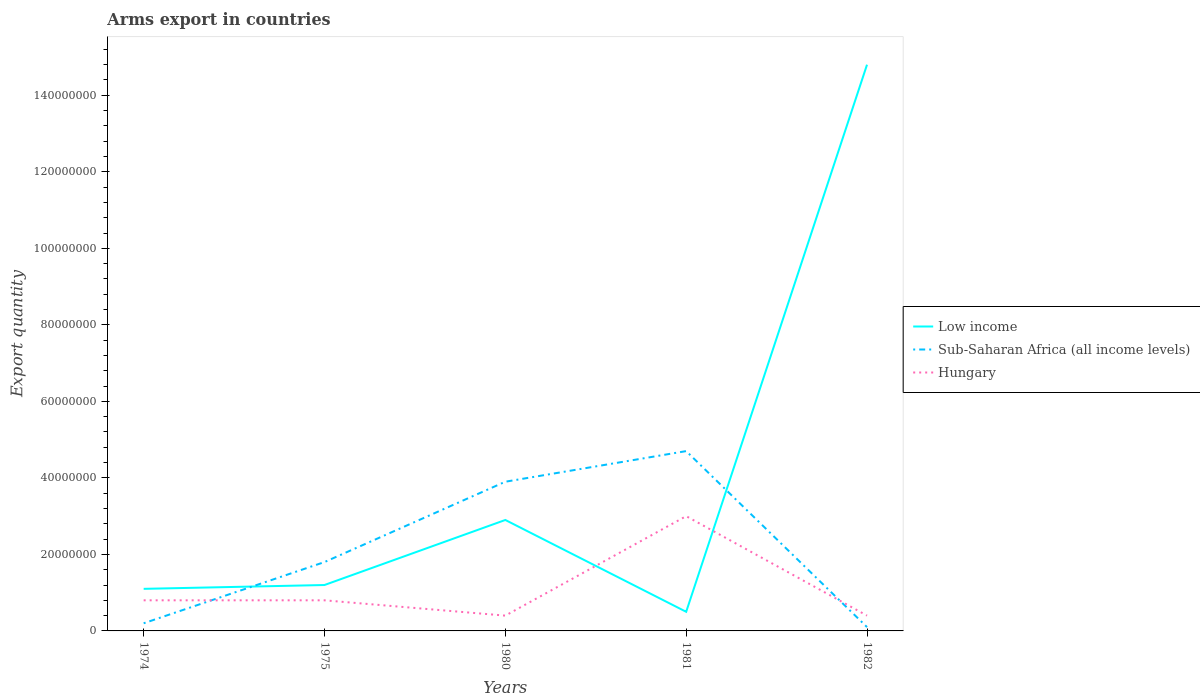How many different coloured lines are there?
Keep it short and to the point. 3. Does the line corresponding to Sub-Saharan Africa (all income levels) intersect with the line corresponding to Hungary?
Make the answer very short. Yes. Is the number of lines equal to the number of legend labels?
Give a very brief answer. Yes. In which year was the total arms export in Sub-Saharan Africa (all income levels) maximum?
Your answer should be very brief. 1982. What is the difference between the highest and the second highest total arms export in Low income?
Offer a terse response. 1.43e+08. How many years are there in the graph?
Your answer should be compact. 5. What is the difference between two consecutive major ticks on the Y-axis?
Provide a succinct answer. 2.00e+07. Where does the legend appear in the graph?
Provide a short and direct response. Center right. How are the legend labels stacked?
Keep it short and to the point. Vertical. What is the title of the graph?
Provide a short and direct response. Arms export in countries. What is the label or title of the Y-axis?
Your answer should be compact. Export quantity. What is the Export quantity in Low income in 1974?
Provide a succinct answer. 1.10e+07. What is the Export quantity of Sub-Saharan Africa (all income levels) in 1974?
Offer a very short reply. 2.00e+06. What is the Export quantity in Sub-Saharan Africa (all income levels) in 1975?
Your response must be concise. 1.80e+07. What is the Export quantity of Low income in 1980?
Provide a short and direct response. 2.90e+07. What is the Export quantity of Sub-Saharan Africa (all income levels) in 1980?
Keep it short and to the point. 3.90e+07. What is the Export quantity of Hungary in 1980?
Ensure brevity in your answer.  4.00e+06. What is the Export quantity of Sub-Saharan Africa (all income levels) in 1981?
Your answer should be compact. 4.70e+07. What is the Export quantity in Hungary in 1981?
Keep it short and to the point. 3.00e+07. What is the Export quantity in Low income in 1982?
Your answer should be compact. 1.48e+08. What is the Export quantity of Sub-Saharan Africa (all income levels) in 1982?
Provide a succinct answer. 1.00e+06. Across all years, what is the maximum Export quantity in Low income?
Your answer should be very brief. 1.48e+08. Across all years, what is the maximum Export quantity of Sub-Saharan Africa (all income levels)?
Make the answer very short. 4.70e+07. Across all years, what is the maximum Export quantity of Hungary?
Make the answer very short. 3.00e+07. Across all years, what is the minimum Export quantity in Sub-Saharan Africa (all income levels)?
Give a very brief answer. 1.00e+06. Across all years, what is the minimum Export quantity of Hungary?
Give a very brief answer. 4.00e+06. What is the total Export quantity in Low income in the graph?
Your response must be concise. 2.05e+08. What is the total Export quantity in Sub-Saharan Africa (all income levels) in the graph?
Give a very brief answer. 1.07e+08. What is the total Export quantity in Hungary in the graph?
Make the answer very short. 5.40e+07. What is the difference between the Export quantity in Sub-Saharan Africa (all income levels) in 1974 and that in 1975?
Provide a succinct answer. -1.60e+07. What is the difference between the Export quantity in Low income in 1974 and that in 1980?
Provide a succinct answer. -1.80e+07. What is the difference between the Export quantity of Sub-Saharan Africa (all income levels) in 1974 and that in 1980?
Your answer should be very brief. -3.70e+07. What is the difference between the Export quantity in Low income in 1974 and that in 1981?
Give a very brief answer. 6.00e+06. What is the difference between the Export quantity in Sub-Saharan Africa (all income levels) in 1974 and that in 1981?
Keep it short and to the point. -4.50e+07. What is the difference between the Export quantity of Hungary in 1974 and that in 1981?
Offer a very short reply. -2.20e+07. What is the difference between the Export quantity of Low income in 1974 and that in 1982?
Provide a succinct answer. -1.37e+08. What is the difference between the Export quantity of Sub-Saharan Africa (all income levels) in 1974 and that in 1982?
Provide a short and direct response. 1.00e+06. What is the difference between the Export quantity in Hungary in 1974 and that in 1982?
Your response must be concise. 4.00e+06. What is the difference between the Export quantity of Low income in 1975 and that in 1980?
Offer a terse response. -1.70e+07. What is the difference between the Export quantity of Sub-Saharan Africa (all income levels) in 1975 and that in 1980?
Provide a succinct answer. -2.10e+07. What is the difference between the Export quantity in Low income in 1975 and that in 1981?
Give a very brief answer. 7.00e+06. What is the difference between the Export quantity in Sub-Saharan Africa (all income levels) in 1975 and that in 1981?
Ensure brevity in your answer.  -2.90e+07. What is the difference between the Export quantity of Hungary in 1975 and that in 1981?
Your answer should be very brief. -2.20e+07. What is the difference between the Export quantity in Low income in 1975 and that in 1982?
Your answer should be compact. -1.36e+08. What is the difference between the Export quantity in Sub-Saharan Africa (all income levels) in 1975 and that in 1982?
Ensure brevity in your answer.  1.70e+07. What is the difference between the Export quantity in Hungary in 1975 and that in 1982?
Offer a terse response. 4.00e+06. What is the difference between the Export quantity of Low income in 1980 and that in 1981?
Provide a short and direct response. 2.40e+07. What is the difference between the Export quantity of Sub-Saharan Africa (all income levels) in 1980 and that in 1981?
Give a very brief answer. -8.00e+06. What is the difference between the Export quantity in Hungary in 1980 and that in 1981?
Your answer should be compact. -2.60e+07. What is the difference between the Export quantity in Low income in 1980 and that in 1982?
Make the answer very short. -1.19e+08. What is the difference between the Export quantity in Sub-Saharan Africa (all income levels) in 1980 and that in 1982?
Provide a short and direct response. 3.80e+07. What is the difference between the Export quantity in Hungary in 1980 and that in 1982?
Make the answer very short. 0. What is the difference between the Export quantity of Low income in 1981 and that in 1982?
Your answer should be very brief. -1.43e+08. What is the difference between the Export quantity in Sub-Saharan Africa (all income levels) in 1981 and that in 1982?
Provide a short and direct response. 4.60e+07. What is the difference between the Export quantity of Hungary in 1981 and that in 1982?
Your answer should be very brief. 2.60e+07. What is the difference between the Export quantity in Low income in 1974 and the Export quantity in Sub-Saharan Africa (all income levels) in 1975?
Provide a short and direct response. -7.00e+06. What is the difference between the Export quantity of Low income in 1974 and the Export quantity of Hungary in 1975?
Provide a short and direct response. 3.00e+06. What is the difference between the Export quantity of Sub-Saharan Africa (all income levels) in 1974 and the Export quantity of Hungary in 1975?
Provide a succinct answer. -6.00e+06. What is the difference between the Export quantity of Low income in 1974 and the Export quantity of Sub-Saharan Africa (all income levels) in 1980?
Provide a short and direct response. -2.80e+07. What is the difference between the Export quantity in Low income in 1974 and the Export quantity in Hungary in 1980?
Provide a succinct answer. 7.00e+06. What is the difference between the Export quantity of Low income in 1974 and the Export quantity of Sub-Saharan Africa (all income levels) in 1981?
Ensure brevity in your answer.  -3.60e+07. What is the difference between the Export quantity in Low income in 1974 and the Export quantity in Hungary in 1981?
Provide a succinct answer. -1.90e+07. What is the difference between the Export quantity of Sub-Saharan Africa (all income levels) in 1974 and the Export quantity of Hungary in 1981?
Make the answer very short. -2.80e+07. What is the difference between the Export quantity in Low income in 1974 and the Export quantity in Hungary in 1982?
Your answer should be compact. 7.00e+06. What is the difference between the Export quantity of Sub-Saharan Africa (all income levels) in 1974 and the Export quantity of Hungary in 1982?
Make the answer very short. -2.00e+06. What is the difference between the Export quantity of Low income in 1975 and the Export quantity of Sub-Saharan Africa (all income levels) in 1980?
Your answer should be very brief. -2.70e+07. What is the difference between the Export quantity of Low income in 1975 and the Export quantity of Hungary in 1980?
Keep it short and to the point. 8.00e+06. What is the difference between the Export quantity of Sub-Saharan Africa (all income levels) in 1975 and the Export quantity of Hungary in 1980?
Your response must be concise. 1.40e+07. What is the difference between the Export quantity of Low income in 1975 and the Export quantity of Sub-Saharan Africa (all income levels) in 1981?
Your response must be concise. -3.50e+07. What is the difference between the Export quantity in Low income in 1975 and the Export quantity in Hungary in 1981?
Make the answer very short. -1.80e+07. What is the difference between the Export quantity in Sub-Saharan Africa (all income levels) in 1975 and the Export quantity in Hungary in 1981?
Make the answer very short. -1.20e+07. What is the difference between the Export quantity in Low income in 1975 and the Export quantity in Sub-Saharan Africa (all income levels) in 1982?
Offer a terse response. 1.10e+07. What is the difference between the Export quantity of Sub-Saharan Africa (all income levels) in 1975 and the Export quantity of Hungary in 1982?
Provide a short and direct response. 1.40e+07. What is the difference between the Export quantity in Low income in 1980 and the Export quantity in Sub-Saharan Africa (all income levels) in 1981?
Keep it short and to the point. -1.80e+07. What is the difference between the Export quantity of Sub-Saharan Africa (all income levels) in 1980 and the Export quantity of Hungary in 1981?
Your answer should be compact. 9.00e+06. What is the difference between the Export quantity in Low income in 1980 and the Export quantity in Sub-Saharan Africa (all income levels) in 1982?
Offer a very short reply. 2.80e+07. What is the difference between the Export quantity in Low income in 1980 and the Export quantity in Hungary in 1982?
Your answer should be compact. 2.50e+07. What is the difference between the Export quantity in Sub-Saharan Africa (all income levels) in 1980 and the Export quantity in Hungary in 1982?
Provide a succinct answer. 3.50e+07. What is the difference between the Export quantity of Low income in 1981 and the Export quantity of Hungary in 1982?
Offer a terse response. 1.00e+06. What is the difference between the Export quantity of Sub-Saharan Africa (all income levels) in 1981 and the Export quantity of Hungary in 1982?
Provide a succinct answer. 4.30e+07. What is the average Export quantity in Low income per year?
Make the answer very short. 4.10e+07. What is the average Export quantity of Sub-Saharan Africa (all income levels) per year?
Your response must be concise. 2.14e+07. What is the average Export quantity in Hungary per year?
Give a very brief answer. 1.08e+07. In the year 1974, what is the difference between the Export quantity of Low income and Export quantity of Sub-Saharan Africa (all income levels)?
Provide a short and direct response. 9.00e+06. In the year 1974, what is the difference between the Export quantity of Low income and Export quantity of Hungary?
Your response must be concise. 3.00e+06. In the year 1974, what is the difference between the Export quantity in Sub-Saharan Africa (all income levels) and Export quantity in Hungary?
Keep it short and to the point. -6.00e+06. In the year 1975, what is the difference between the Export quantity in Low income and Export quantity in Sub-Saharan Africa (all income levels)?
Your response must be concise. -6.00e+06. In the year 1975, what is the difference between the Export quantity of Sub-Saharan Africa (all income levels) and Export quantity of Hungary?
Keep it short and to the point. 1.00e+07. In the year 1980, what is the difference between the Export quantity in Low income and Export quantity in Sub-Saharan Africa (all income levels)?
Your response must be concise. -1.00e+07. In the year 1980, what is the difference between the Export quantity in Low income and Export quantity in Hungary?
Keep it short and to the point. 2.50e+07. In the year 1980, what is the difference between the Export quantity in Sub-Saharan Africa (all income levels) and Export quantity in Hungary?
Make the answer very short. 3.50e+07. In the year 1981, what is the difference between the Export quantity in Low income and Export quantity in Sub-Saharan Africa (all income levels)?
Provide a short and direct response. -4.20e+07. In the year 1981, what is the difference between the Export quantity of Low income and Export quantity of Hungary?
Your response must be concise. -2.50e+07. In the year 1981, what is the difference between the Export quantity of Sub-Saharan Africa (all income levels) and Export quantity of Hungary?
Make the answer very short. 1.70e+07. In the year 1982, what is the difference between the Export quantity in Low income and Export quantity in Sub-Saharan Africa (all income levels)?
Provide a short and direct response. 1.47e+08. In the year 1982, what is the difference between the Export quantity of Low income and Export quantity of Hungary?
Provide a succinct answer. 1.44e+08. In the year 1982, what is the difference between the Export quantity of Sub-Saharan Africa (all income levels) and Export quantity of Hungary?
Keep it short and to the point. -3.00e+06. What is the ratio of the Export quantity of Low income in 1974 to that in 1975?
Ensure brevity in your answer.  0.92. What is the ratio of the Export quantity of Sub-Saharan Africa (all income levels) in 1974 to that in 1975?
Offer a very short reply. 0.11. What is the ratio of the Export quantity in Hungary in 1974 to that in 1975?
Provide a short and direct response. 1. What is the ratio of the Export quantity of Low income in 1974 to that in 1980?
Your answer should be compact. 0.38. What is the ratio of the Export quantity in Sub-Saharan Africa (all income levels) in 1974 to that in 1980?
Offer a very short reply. 0.05. What is the ratio of the Export quantity of Low income in 1974 to that in 1981?
Keep it short and to the point. 2.2. What is the ratio of the Export quantity of Sub-Saharan Africa (all income levels) in 1974 to that in 1981?
Provide a succinct answer. 0.04. What is the ratio of the Export quantity in Hungary in 1974 to that in 1981?
Ensure brevity in your answer.  0.27. What is the ratio of the Export quantity in Low income in 1974 to that in 1982?
Offer a very short reply. 0.07. What is the ratio of the Export quantity of Sub-Saharan Africa (all income levels) in 1974 to that in 1982?
Your answer should be compact. 2. What is the ratio of the Export quantity in Hungary in 1974 to that in 1982?
Provide a succinct answer. 2. What is the ratio of the Export quantity of Low income in 1975 to that in 1980?
Provide a succinct answer. 0.41. What is the ratio of the Export quantity of Sub-Saharan Africa (all income levels) in 1975 to that in 1980?
Your answer should be very brief. 0.46. What is the ratio of the Export quantity of Sub-Saharan Africa (all income levels) in 1975 to that in 1981?
Your answer should be very brief. 0.38. What is the ratio of the Export quantity in Hungary in 1975 to that in 1981?
Ensure brevity in your answer.  0.27. What is the ratio of the Export quantity in Low income in 1975 to that in 1982?
Ensure brevity in your answer.  0.08. What is the ratio of the Export quantity in Sub-Saharan Africa (all income levels) in 1975 to that in 1982?
Your answer should be compact. 18. What is the ratio of the Export quantity of Hungary in 1975 to that in 1982?
Offer a very short reply. 2. What is the ratio of the Export quantity in Low income in 1980 to that in 1981?
Offer a terse response. 5.8. What is the ratio of the Export quantity in Sub-Saharan Africa (all income levels) in 1980 to that in 1981?
Provide a short and direct response. 0.83. What is the ratio of the Export quantity of Hungary in 1980 to that in 1981?
Your answer should be compact. 0.13. What is the ratio of the Export quantity in Low income in 1980 to that in 1982?
Keep it short and to the point. 0.2. What is the ratio of the Export quantity in Sub-Saharan Africa (all income levels) in 1980 to that in 1982?
Give a very brief answer. 39. What is the ratio of the Export quantity in Low income in 1981 to that in 1982?
Provide a short and direct response. 0.03. What is the ratio of the Export quantity in Sub-Saharan Africa (all income levels) in 1981 to that in 1982?
Provide a short and direct response. 47. What is the difference between the highest and the second highest Export quantity in Low income?
Your response must be concise. 1.19e+08. What is the difference between the highest and the second highest Export quantity in Sub-Saharan Africa (all income levels)?
Make the answer very short. 8.00e+06. What is the difference between the highest and the second highest Export quantity of Hungary?
Offer a very short reply. 2.20e+07. What is the difference between the highest and the lowest Export quantity of Low income?
Provide a succinct answer. 1.43e+08. What is the difference between the highest and the lowest Export quantity in Sub-Saharan Africa (all income levels)?
Offer a very short reply. 4.60e+07. What is the difference between the highest and the lowest Export quantity of Hungary?
Your response must be concise. 2.60e+07. 